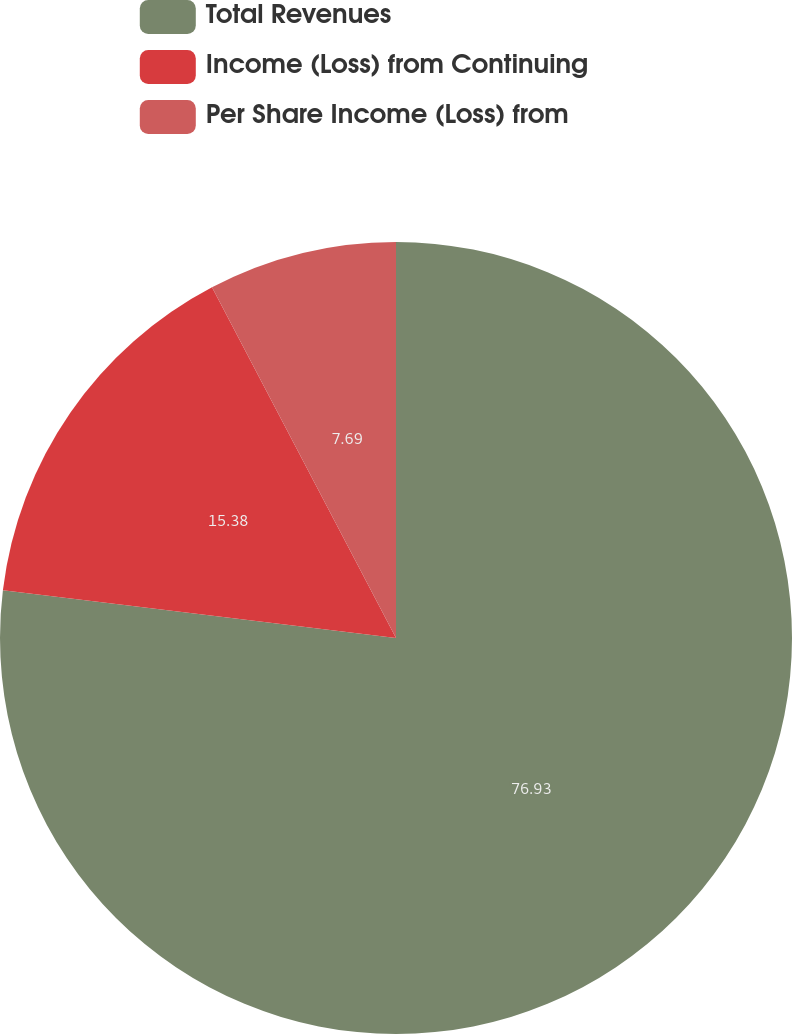Convert chart to OTSL. <chart><loc_0><loc_0><loc_500><loc_500><pie_chart><fcel>Total Revenues<fcel>Income (Loss) from Continuing<fcel>Per Share Income (Loss) from<nl><fcel>76.92%<fcel>15.38%<fcel>7.69%<nl></chart> 